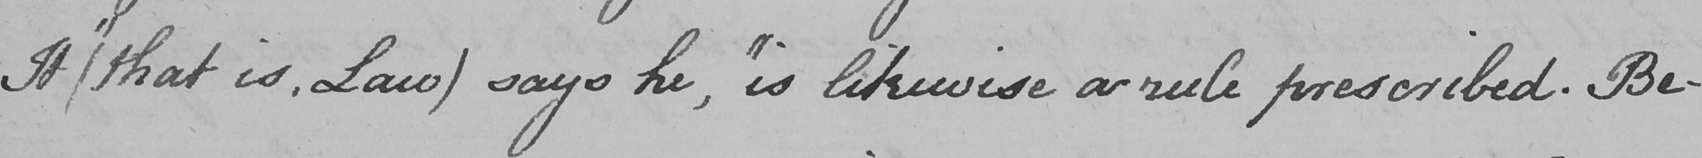Please transcribe the handwritten text in this image. It  ( that is , Law )  says he ,  " is likewise a rule prescribed . Be- 